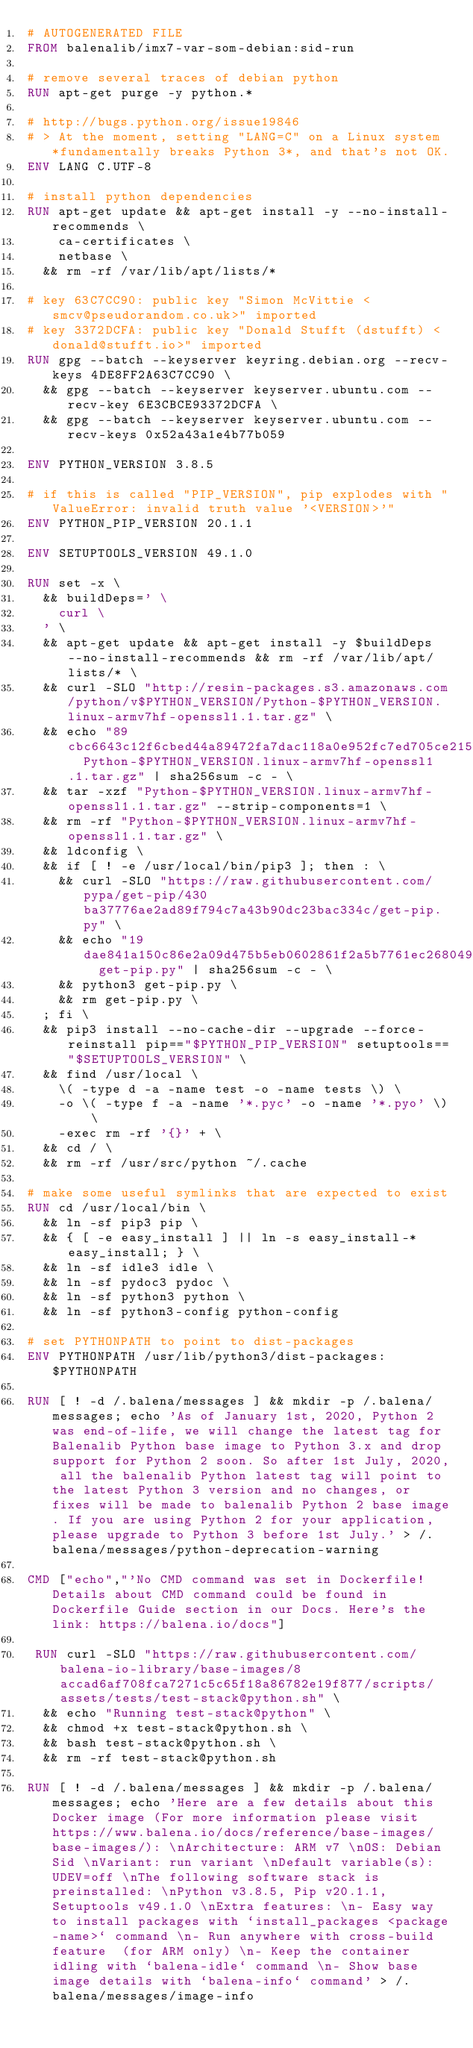<code> <loc_0><loc_0><loc_500><loc_500><_Dockerfile_># AUTOGENERATED FILE
FROM balenalib/imx7-var-som-debian:sid-run

# remove several traces of debian python
RUN apt-get purge -y python.*

# http://bugs.python.org/issue19846
# > At the moment, setting "LANG=C" on a Linux system *fundamentally breaks Python 3*, and that's not OK.
ENV LANG C.UTF-8

# install python dependencies
RUN apt-get update && apt-get install -y --no-install-recommends \
		ca-certificates \
		netbase \
	&& rm -rf /var/lib/apt/lists/*

# key 63C7CC90: public key "Simon McVittie <smcv@pseudorandom.co.uk>" imported
# key 3372DCFA: public key "Donald Stufft (dstufft) <donald@stufft.io>" imported
RUN gpg --batch --keyserver keyring.debian.org --recv-keys 4DE8FF2A63C7CC90 \
	&& gpg --batch --keyserver keyserver.ubuntu.com --recv-key 6E3CBCE93372DCFA \
	&& gpg --batch --keyserver keyserver.ubuntu.com --recv-keys 0x52a43a1e4b77b059

ENV PYTHON_VERSION 3.8.5

# if this is called "PIP_VERSION", pip explodes with "ValueError: invalid truth value '<VERSION>'"
ENV PYTHON_PIP_VERSION 20.1.1

ENV SETUPTOOLS_VERSION 49.1.0

RUN set -x \
	&& buildDeps=' \
		curl \
	' \
	&& apt-get update && apt-get install -y $buildDeps --no-install-recommends && rm -rf /var/lib/apt/lists/* \
	&& curl -SLO "http://resin-packages.s3.amazonaws.com/python/v$PYTHON_VERSION/Python-$PYTHON_VERSION.linux-armv7hf-openssl1.1.tar.gz" \
	&& echo "89cbc6643c12f6cbed44a89472fa7dac118a0e952fc7ed705ce2151a96c9ab8e  Python-$PYTHON_VERSION.linux-armv7hf-openssl1.1.tar.gz" | sha256sum -c - \
	&& tar -xzf "Python-$PYTHON_VERSION.linux-armv7hf-openssl1.1.tar.gz" --strip-components=1 \
	&& rm -rf "Python-$PYTHON_VERSION.linux-armv7hf-openssl1.1.tar.gz" \
	&& ldconfig \
	&& if [ ! -e /usr/local/bin/pip3 ]; then : \
		&& curl -SLO "https://raw.githubusercontent.com/pypa/get-pip/430ba37776ae2ad89f794c7a43b90dc23bac334c/get-pip.py" \
		&& echo "19dae841a150c86e2a09d475b5eb0602861f2a5b7761ec268049a662dbd2bd0c  get-pip.py" | sha256sum -c - \
		&& python3 get-pip.py \
		&& rm get-pip.py \
	; fi \
	&& pip3 install --no-cache-dir --upgrade --force-reinstall pip=="$PYTHON_PIP_VERSION" setuptools=="$SETUPTOOLS_VERSION" \
	&& find /usr/local \
		\( -type d -a -name test -o -name tests \) \
		-o \( -type f -a -name '*.pyc' -o -name '*.pyo' \) \
		-exec rm -rf '{}' + \
	&& cd / \
	&& rm -rf /usr/src/python ~/.cache

# make some useful symlinks that are expected to exist
RUN cd /usr/local/bin \
	&& ln -sf pip3 pip \
	&& { [ -e easy_install ] || ln -s easy_install-* easy_install; } \
	&& ln -sf idle3 idle \
	&& ln -sf pydoc3 pydoc \
	&& ln -sf python3 python \
	&& ln -sf python3-config python-config

# set PYTHONPATH to point to dist-packages
ENV PYTHONPATH /usr/lib/python3/dist-packages:$PYTHONPATH

RUN [ ! -d /.balena/messages ] && mkdir -p /.balena/messages; echo 'As of January 1st, 2020, Python 2 was end-of-life, we will change the latest tag for Balenalib Python base image to Python 3.x and drop support for Python 2 soon. So after 1st July, 2020, all the balenalib Python latest tag will point to the latest Python 3 version and no changes, or fixes will be made to balenalib Python 2 base image. If you are using Python 2 for your application, please upgrade to Python 3 before 1st July.' > /.balena/messages/python-deprecation-warning

CMD ["echo","'No CMD command was set in Dockerfile! Details about CMD command could be found in Dockerfile Guide section in our Docs. Here's the link: https://balena.io/docs"]

 RUN curl -SLO "https://raw.githubusercontent.com/balena-io-library/base-images/8accad6af708fca7271c5c65f18a86782e19f877/scripts/assets/tests/test-stack@python.sh" \
  && echo "Running test-stack@python" \
  && chmod +x test-stack@python.sh \
  && bash test-stack@python.sh \
  && rm -rf test-stack@python.sh 

RUN [ ! -d /.balena/messages ] && mkdir -p /.balena/messages; echo 'Here are a few details about this Docker image (For more information please visit https://www.balena.io/docs/reference/base-images/base-images/): \nArchitecture: ARM v7 \nOS: Debian Sid \nVariant: run variant \nDefault variable(s): UDEV=off \nThe following software stack is preinstalled: \nPython v3.8.5, Pip v20.1.1, Setuptools v49.1.0 \nExtra features: \n- Easy way to install packages with `install_packages <package-name>` command \n- Run anywhere with cross-build feature  (for ARM only) \n- Keep the container idling with `balena-idle` command \n- Show base image details with `balena-info` command' > /.balena/messages/image-info
</code> 